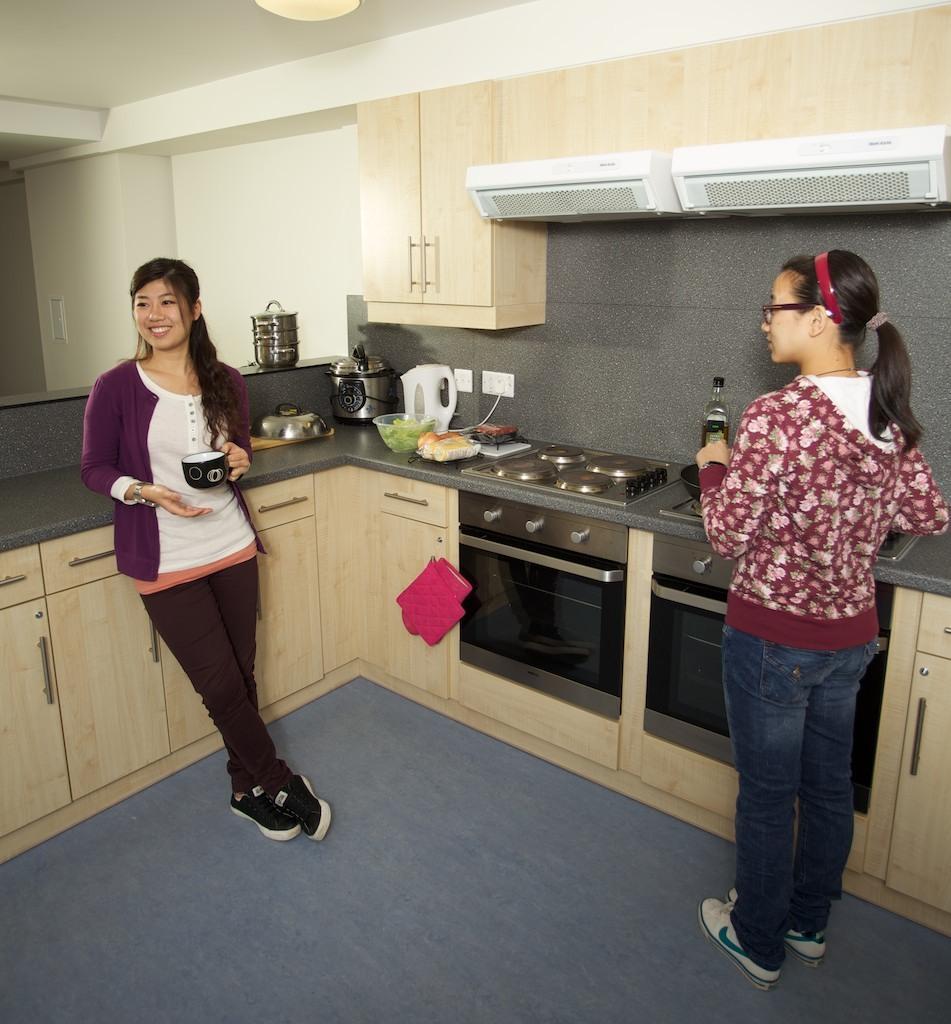Can you describe this image briefly? In this picture there are two women who are standing near to the kitchen platform. On the platform I can see the oven, bread, bowl, cabbage, mixer and other objects. At the top I can see the cupboards and exhaust ducts. In the top left I can see the light on the roof. 